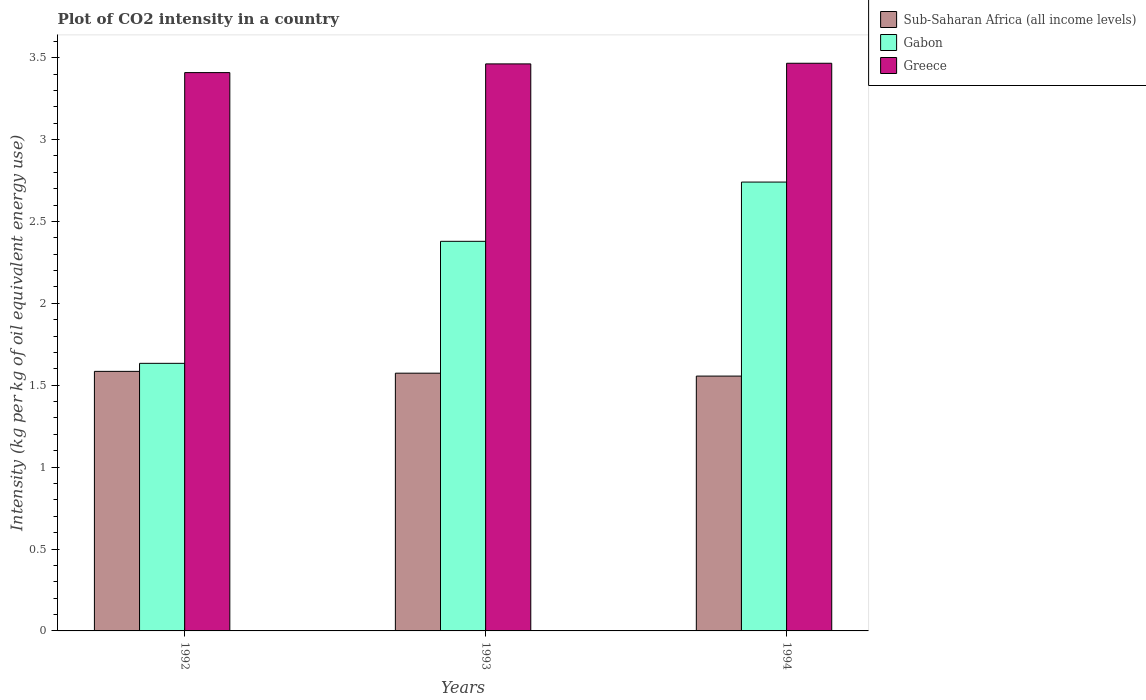How many groups of bars are there?
Offer a very short reply. 3. Are the number of bars per tick equal to the number of legend labels?
Make the answer very short. Yes. Are the number of bars on each tick of the X-axis equal?
Keep it short and to the point. Yes. How many bars are there on the 1st tick from the right?
Keep it short and to the point. 3. What is the label of the 2nd group of bars from the left?
Make the answer very short. 1993. In how many cases, is the number of bars for a given year not equal to the number of legend labels?
Make the answer very short. 0. What is the CO2 intensity in in Gabon in 1992?
Keep it short and to the point. 1.63. Across all years, what is the maximum CO2 intensity in in Sub-Saharan Africa (all income levels)?
Provide a succinct answer. 1.58. Across all years, what is the minimum CO2 intensity in in Greece?
Provide a succinct answer. 3.41. In which year was the CO2 intensity in in Sub-Saharan Africa (all income levels) maximum?
Your response must be concise. 1992. What is the total CO2 intensity in in Sub-Saharan Africa (all income levels) in the graph?
Offer a very short reply. 4.71. What is the difference between the CO2 intensity in in Greece in 1993 and that in 1994?
Provide a short and direct response. -0. What is the difference between the CO2 intensity in in Gabon in 1993 and the CO2 intensity in in Sub-Saharan Africa (all income levels) in 1994?
Make the answer very short. 0.82. What is the average CO2 intensity in in Sub-Saharan Africa (all income levels) per year?
Provide a succinct answer. 1.57. In the year 1993, what is the difference between the CO2 intensity in in Gabon and CO2 intensity in in Sub-Saharan Africa (all income levels)?
Ensure brevity in your answer.  0.81. In how many years, is the CO2 intensity in in Greece greater than 1.9 kg?
Your answer should be compact. 3. What is the ratio of the CO2 intensity in in Greece in 1992 to that in 1994?
Offer a very short reply. 0.98. Is the CO2 intensity in in Greece in 1992 less than that in 1994?
Offer a very short reply. Yes. Is the difference between the CO2 intensity in in Gabon in 1992 and 1993 greater than the difference between the CO2 intensity in in Sub-Saharan Africa (all income levels) in 1992 and 1993?
Your answer should be compact. No. What is the difference between the highest and the second highest CO2 intensity in in Sub-Saharan Africa (all income levels)?
Provide a succinct answer. 0.01. What is the difference between the highest and the lowest CO2 intensity in in Sub-Saharan Africa (all income levels)?
Your answer should be compact. 0.03. What does the 1st bar from the left in 1993 represents?
Offer a very short reply. Sub-Saharan Africa (all income levels). What does the 2nd bar from the right in 1993 represents?
Offer a terse response. Gabon. Is it the case that in every year, the sum of the CO2 intensity in in Sub-Saharan Africa (all income levels) and CO2 intensity in in Gabon is greater than the CO2 intensity in in Greece?
Your answer should be compact. No. How many bars are there?
Your answer should be very brief. 9. How many legend labels are there?
Keep it short and to the point. 3. How are the legend labels stacked?
Offer a terse response. Vertical. What is the title of the graph?
Your answer should be very brief. Plot of CO2 intensity in a country. Does "Lithuania" appear as one of the legend labels in the graph?
Provide a short and direct response. No. What is the label or title of the X-axis?
Your answer should be very brief. Years. What is the label or title of the Y-axis?
Give a very brief answer. Intensity (kg per kg of oil equivalent energy use). What is the Intensity (kg per kg of oil equivalent energy use) in Sub-Saharan Africa (all income levels) in 1992?
Your answer should be compact. 1.58. What is the Intensity (kg per kg of oil equivalent energy use) of Gabon in 1992?
Ensure brevity in your answer.  1.63. What is the Intensity (kg per kg of oil equivalent energy use) in Greece in 1992?
Your answer should be very brief. 3.41. What is the Intensity (kg per kg of oil equivalent energy use) in Sub-Saharan Africa (all income levels) in 1993?
Keep it short and to the point. 1.57. What is the Intensity (kg per kg of oil equivalent energy use) of Gabon in 1993?
Make the answer very short. 2.38. What is the Intensity (kg per kg of oil equivalent energy use) in Greece in 1993?
Provide a short and direct response. 3.46. What is the Intensity (kg per kg of oil equivalent energy use) in Sub-Saharan Africa (all income levels) in 1994?
Your response must be concise. 1.56. What is the Intensity (kg per kg of oil equivalent energy use) in Gabon in 1994?
Ensure brevity in your answer.  2.74. What is the Intensity (kg per kg of oil equivalent energy use) of Greece in 1994?
Your answer should be compact. 3.47. Across all years, what is the maximum Intensity (kg per kg of oil equivalent energy use) in Sub-Saharan Africa (all income levels)?
Offer a terse response. 1.58. Across all years, what is the maximum Intensity (kg per kg of oil equivalent energy use) in Gabon?
Ensure brevity in your answer.  2.74. Across all years, what is the maximum Intensity (kg per kg of oil equivalent energy use) in Greece?
Offer a very short reply. 3.47. Across all years, what is the minimum Intensity (kg per kg of oil equivalent energy use) in Sub-Saharan Africa (all income levels)?
Make the answer very short. 1.56. Across all years, what is the minimum Intensity (kg per kg of oil equivalent energy use) in Gabon?
Your answer should be compact. 1.63. Across all years, what is the minimum Intensity (kg per kg of oil equivalent energy use) in Greece?
Ensure brevity in your answer.  3.41. What is the total Intensity (kg per kg of oil equivalent energy use) of Sub-Saharan Africa (all income levels) in the graph?
Your answer should be very brief. 4.71. What is the total Intensity (kg per kg of oil equivalent energy use) of Gabon in the graph?
Offer a very short reply. 6.75. What is the total Intensity (kg per kg of oil equivalent energy use) of Greece in the graph?
Your response must be concise. 10.34. What is the difference between the Intensity (kg per kg of oil equivalent energy use) of Sub-Saharan Africa (all income levels) in 1992 and that in 1993?
Your answer should be compact. 0.01. What is the difference between the Intensity (kg per kg of oil equivalent energy use) in Gabon in 1992 and that in 1993?
Your answer should be very brief. -0.74. What is the difference between the Intensity (kg per kg of oil equivalent energy use) of Greece in 1992 and that in 1993?
Give a very brief answer. -0.05. What is the difference between the Intensity (kg per kg of oil equivalent energy use) in Sub-Saharan Africa (all income levels) in 1992 and that in 1994?
Offer a very short reply. 0.03. What is the difference between the Intensity (kg per kg of oil equivalent energy use) of Gabon in 1992 and that in 1994?
Offer a terse response. -1.11. What is the difference between the Intensity (kg per kg of oil equivalent energy use) in Greece in 1992 and that in 1994?
Give a very brief answer. -0.06. What is the difference between the Intensity (kg per kg of oil equivalent energy use) in Sub-Saharan Africa (all income levels) in 1993 and that in 1994?
Make the answer very short. 0.02. What is the difference between the Intensity (kg per kg of oil equivalent energy use) in Gabon in 1993 and that in 1994?
Ensure brevity in your answer.  -0.36. What is the difference between the Intensity (kg per kg of oil equivalent energy use) of Greece in 1993 and that in 1994?
Your response must be concise. -0. What is the difference between the Intensity (kg per kg of oil equivalent energy use) of Sub-Saharan Africa (all income levels) in 1992 and the Intensity (kg per kg of oil equivalent energy use) of Gabon in 1993?
Make the answer very short. -0.79. What is the difference between the Intensity (kg per kg of oil equivalent energy use) in Sub-Saharan Africa (all income levels) in 1992 and the Intensity (kg per kg of oil equivalent energy use) in Greece in 1993?
Provide a succinct answer. -1.88. What is the difference between the Intensity (kg per kg of oil equivalent energy use) of Gabon in 1992 and the Intensity (kg per kg of oil equivalent energy use) of Greece in 1993?
Offer a very short reply. -1.83. What is the difference between the Intensity (kg per kg of oil equivalent energy use) in Sub-Saharan Africa (all income levels) in 1992 and the Intensity (kg per kg of oil equivalent energy use) in Gabon in 1994?
Your answer should be very brief. -1.16. What is the difference between the Intensity (kg per kg of oil equivalent energy use) in Sub-Saharan Africa (all income levels) in 1992 and the Intensity (kg per kg of oil equivalent energy use) in Greece in 1994?
Offer a terse response. -1.88. What is the difference between the Intensity (kg per kg of oil equivalent energy use) of Gabon in 1992 and the Intensity (kg per kg of oil equivalent energy use) of Greece in 1994?
Provide a succinct answer. -1.83. What is the difference between the Intensity (kg per kg of oil equivalent energy use) of Sub-Saharan Africa (all income levels) in 1993 and the Intensity (kg per kg of oil equivalent energy use) of Gabon in 1994?
Make the answer very short. -1.17. What is the difference between the Intensity (kg per kg of oil equivalent energy use) of Sub-Saharan Africa (all income levels) in 1993 and the Intensity (kg per kg of oil equivalent energy use) of Greece in 1994?
Ensure brevity in your answer.  -1.89. What is the difference between the Intensity (kg per kg of oil equivalent energy use) of Gabon in 1993 and the Intensity (kg per kg of oil equivalent energy use) of Greece in 1994?
Make the answer very short. -1.09. What is the average Intensity (kg per kg of oil equivalent energy use) in Sub-Saharan Africa (all income levels) per year?
Keep it short and to the point. 1.57. What is the average Intensity (kg per kg of oil equivalent energy use) in Gabon per year?
Keep it short and to the point. 2.25. What is the average Intensity (kg per kg of oil equivalent energy use) in Greece per year?
Offer a very short reply. 3.45. In the year 1992, what is the difference between the Intensity (kg per kg of oil equivalent energy use) of Sub-Saharan Africa (all income levels) and Intensity (kg per kg of oil equivalent energy use) of Gabon?
Keep it short and to the point. -0.05. In the year 1992, what is the difference between the Intensity (kg per kg of oil equivalent energy use) in Sub-Saharan Africa (all income levels) and Intensity (kg per kg of oil equivalent energy use) in Greece?
Provide a succinct answer. -1.82. In the year 1992, what is the difference between the Intensity (kg per kg of oil equivalent energy use) of Gabon and Intensity (kg per kg of oil equivalent energy use) of Greece?
Your response must be concise. -1.77. In the year 1993, what is the difference between the Intensity (kg per kg of oil equivalent energy use) of Sub-Saharan Africa (all income levels) and Intensity (kg per kg of oil equivalent energy use) of Gabon?
Offer a very short reply. -0.81. In the year 1993, what is the difference between the Intensity (kg per kg of oil equivalent energy use) of Sub-Saharan Africa (all income levels) and Intensity (kg per kg of oil equivalent energy use) of Greece?
Offer a very short reply. -1.89. In the year 1993, what is the difference between the Intensity (kg per kg of oil equivalent energy use) in Gabon and Intensity (kg per kg of oil equivalent energy use) in Greece?
Offer a terse response. -1.08. In the year 1994, what is the difference between the Intensity (kg per kg of oil equivalent energy use) in Sub-Saharan Africa (all income levels) and Intensity (kg per kg of oil equivalent energy use) in Gabon?
Offer a very short reply. -1.18. In the year 1994, what is the difference between the Intensity (kg per kg of oil equivalent energy use) of Sub-Saharan Africa (all income levels) and Intensity (kg per kg of oil equivalent energy use) of Greece?
Offer a terse response. -1.91. In the year 1994, what is the difference between the Intensity (kg per kg of oil equivalent energy use) in Gabon and Intensity (kg per kg of oil equivalent energy use) in Greece?
Your response must be concise. -0.73. What is the ratio of the Intensity (kg per kg of oil equivalent energy use) of Sub-Saharan Africa (all income levels) in 1992 to that in 1993?
Your answer should be compact. 1.01. What is the ratio of the Intensity (kg per kg of oil equivalent energy use) of Gabon in 1992 to that in 1993?
Offer a very short reply. 0.69. What is the ratio of the Intensity (kg per kg of oil equivalent energy use) of Greece in 1992 to that in 1993?
Provide a short and direct response. 0.98. What is the ratio of the Intensity (kg per kg of oil equivalent energy use) of Sub-Saharan Africa (all income levels) in 1992 to that in 1994?
Offer a very short reply. 1.02. What is the ratio of the Intensity (kg per kg of oil equivalent energy use) in Gabon in 1992 to that in 1994?
Your answer should be compact. 0.6. What is the ratio of the Intensity (kg per kg of oil equivalent energy use) in Greece in 1992 to that in 1994?
Give a very brief answer. 0.98. What is the ratio of the Intensity (kg per kg of oil equivalent energy use) of Sub-Saharan Africa (all income levels) in 1993 to that in 1994?
Ensure brevity in your answer.  1.01. What is the ratio of the Intensity (kg per kg of oil equivalent energy use) in Gabon in 1993 to that in 1994?
Make the answer very short. 0.87. What is the ratio of the Intensity (kg per kg of oil equivalent energy use) in Greece in 1993 to that in 1994?
Ensure brevity in your answer.  1. What is the difference between the highest and the second highest Intensity (kg per kg of oil equivalent energy use) of Sub-Saharan Africa (all income levels)?
Keep it short and to the point. 0.01. What is the difference between the highest and the second highest Intensity (kg per kg of oil equivalent energy use) of Gabon?
Offer a very short reply. 0.36. What is the difference between the highest and the second highest Intensity (kg per kg of oil equivalent energy use) of Greece?
Ensure brevity in your answer.  0. What is the difference between the highest and the lowest Intensity (kg per kg of oil equivalent energy use) of Sub-Saharan Africa (all income levels)?
Offer a very short reply. 0.03. What is the difference between the highest and the lowest Intensity (kg per kg of oil equivalent energy use) of Gabon?
Your response must be concise. 1.11. What is the difference between the highest and the lowest Intensity (kg per kg of oil equivalent energy use) in Greece?
Keep it short and to the point. 0.06. 